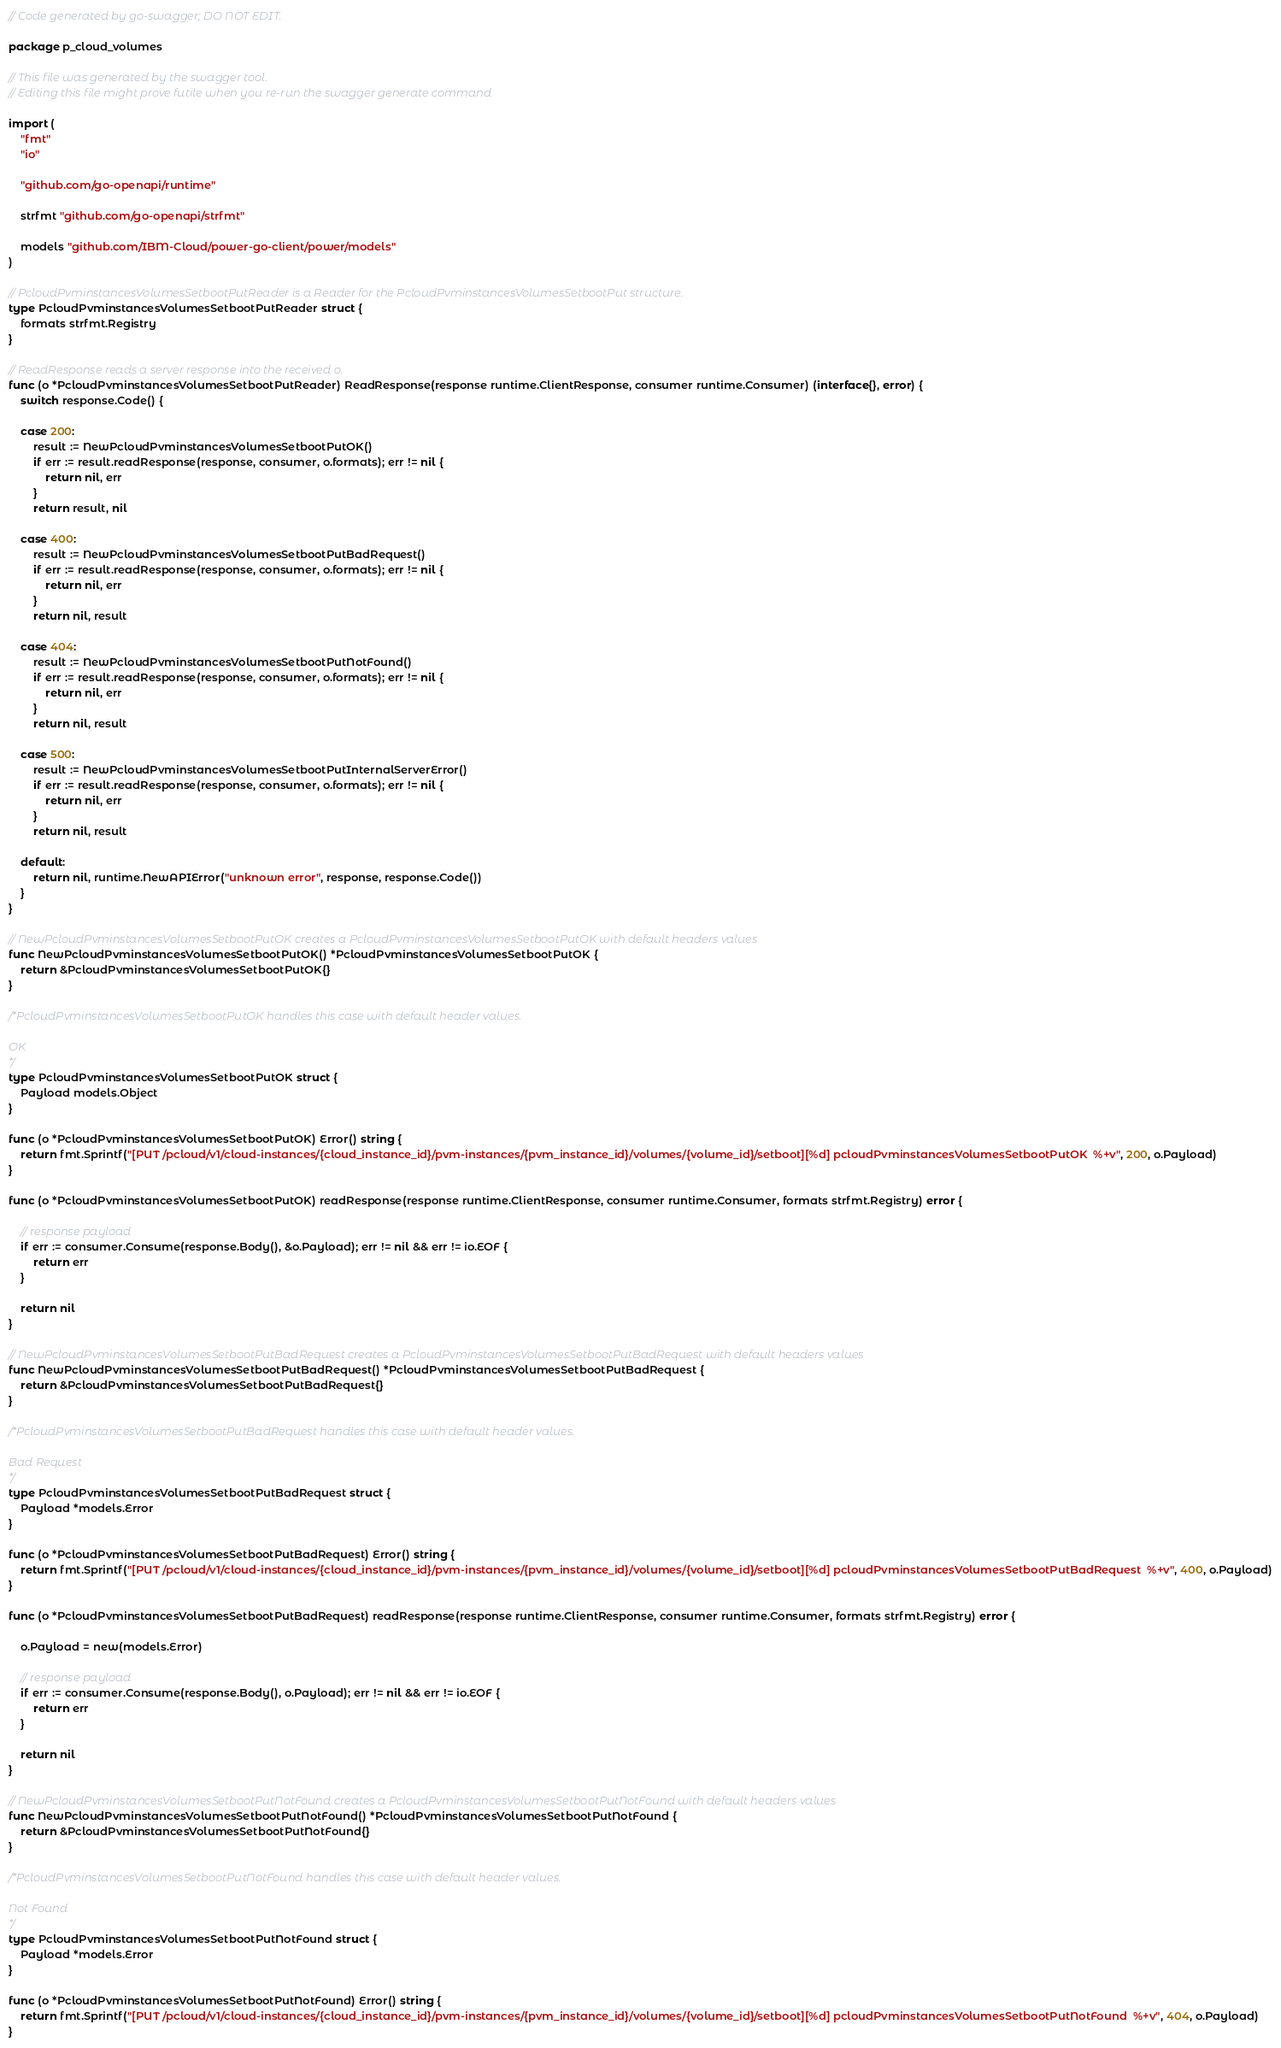Convert code to text. <code><loc_0><loc_0><loc_500><loc_500><_Go_>// Code generated by go-swagger; DO NOT EDIT.

package p_cloud_volumes

// This file was generated by the swagger tool.
// Editing this file might prove futile when you re-run the swagger generate command

import (
	"fmt"
	"io"

	"github.com/go-openapi/runtime"

	strfmt "github.com/go-openapi/strfmt"

	models "github.com/IBM-Cloud/power-go-client/power/models"
)

// PcloudPvminstancesVolumesSetbootPutReader is a Reader for the PcloudPvminstancesVolumesSetbootPut structure.
type PcloudPvminstancesVolumesSetbootPutReader struct {
	formats strfmt.Registry
}

// ReadResponse reads a server response into the received o.
func (o *PcloudPvminstancesVolumesSetbootPutReader) ReadResponse(response runtime.ClientResponse, consumer runtime.Consumer) (interface{}, error) {
	switch response.Code() {

	case 200:
		result := NewPcloudPvminstancesVolumesSetbootPutOK()
		if err := result.readResponse(response, consumer, o.formats); err != nil {
			return nil, err
		}
		return result, nil

	case 400:
		result := NewPcloudPvminstancesVolumesSetbootPutBadRequest()
		if err := result.readResponse(response, consumer, o.formats); err != nil {
			return nil, err
		}
		return nil, result

	case 404:
		result := NewPcloudPvminstancesVolumesSetbootPutNotFound()
		if err := result.readResponse(response, consumer, o.formats); err != nil {
			return nil, err
		}
		return nil, result

	case 500:
		result := NewPcloudPvminstancesVolumesSetbootPutInternalServerError()
		if err := result.readResponse(response, consumer, o.formats); err != nil {
			return nil, err
		}
		return nil, result

	default:
		return nil, runtime.NewAPIError("unknown error", response, response.Code())
	}
}

// NewPcloudPvminstancesVolumesSetbootPutOK creates a PcloudPvminstancesVolumesSetbootPutOK with default headers values
func NewPcloudPvminstancesVolumesSetbootPutOK() *PcloudPvminstancesVolumesSetbootPutOK {
	return &PcloudPvminstancesVolumesSetbootPutOK{}
}

/*PcloudPvminstancesVolumesSetbootPutOK handles this case with default header values.

OK
*/
type PcloudPvminstancesVolumesSetbootPutOK struct {
	Payload models.Object
}

func (o *PcloudPvminstancesVolumesSetbootPutOK) Error() string {
	return fmt.Sprintf("[PUT /pcloud/v1/cloud-instances/{cloud_instance_id}/pvm-instances/{pvm_instance_id}/volumes/{volume_id}/setboot][%d] pcloudPvminstancesVolumesSetbootPutOK  %+v", 200, o.Payload)
}

func (o *PcloudPvminstancesVolumesSetbootPutOK) readResponse(response runtime.ClientResponse, consumer runtime.Consumer, formats strfmt.Registry) error {

	// response payload
	if err := consumer.Consume(response.Body(), &o.Payload); err != nil && err != io.EOF {
		return err
	}

	return nil
}

// NewPcloudPvminstancesVolumesSetbootPutBadRequest creates a PcloudPvminstancesVolumesSetbootPutBadRequest with default headers values
func NewPcloudPvminstancesVolumesSetbootPutBadRequest() *PcloudPvminstancesVolumesSetbootPutBadRequest {
	return &PcloudPvminstancesVolumesSetbootPutBadRequest{}
}

/*PcloudPvminstancesVolumesSetbootPutBadRequest handles this case with default header values.

Bad Request
*/
type PcloudPvminstancesVolumesSetbootPutBadRequest struct {
	Payload *models.Error
}

func (o *PcloudPvminstancesVolumesSetbootPutBadRequest) Error() string {
	return fmt.Sprintf("[PUT /pcloud/v1/cloud-instances/{cloud_instance_id}/pvm-instances/{pvm_instance_id}/volumes/{volume_id}/setboot][%d] pcloudPvminstancesVolumesSetbootPutBadRequest  %+v", 400, o.Payload)
}

func (o *PcloudPvminstancesVolumesSetbootPutBadRequest) readResponse(response runtime.ClientResponse, consumer runtime.Consumer, formats strfmt.Registry) error {

	o.Payload = new(models.Error)

	// response payload
	if err := consumer.Consume(response.Body(), o.Payload); err != nil && err != io.EOF {
		return err
	}

	return nil
}

// NewPcloudPvminstancesVolumesSetbootPutNotFound creates a PcloudPvminstancesVolumesSetbootPutNotFound with default headers values
func NewPcloudPvminstancesVolumesSetbootPutNotFound() *PcloudPvminstancesVolumesSetbootPutNotFound {
	return &PcloudPvminstancesVolumesSetbootPutNotFound{}
}

/*PcloudPvminstancesVolumesSetbootPutNotFound handles this case with default header values.

Not Found
*/
type PcloudPvminstancesVolumesSetbootPutNotFound struct {
	Payload *models.Error
}

func (o *PcloudPvminstancesVolumesSetbootPutNotFound) Error() string {
	return fmt.Sprintf("[PUT /pcloud/v1/cloud-instances/{cloud_instance_id}/pvm-instances/{pvm_instance_id}/volumes/{volume_id}/setboot][%d] pcloudPvminstancesVolumesSetbootPutNotFound  %+v", 404, o.Payload)
}
</code> 